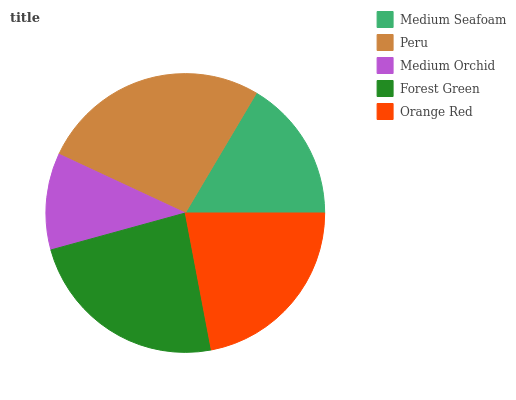Is Medium Orchid the minimum?
Answer yes or no. Yes. Is Peru the maximum?
Answer yes or no. Yes. Is Peru the minimum?
Answer yes or no. No. Is Medium Orchid the maximum?
Answer yes or no. No. Is Peru greater than Medium Orchid?
Answer yes or no. Yes. Is Medium Orchid less than Peru?
Answer yes or no. Yes. Is Medium Orchid greater than Peru?
Answer yes or no. No. Is Peru less than Medium Orchid?
Answer yes or no. No. Is Orange Red the high median?
Answer yes or no. Yes. Is Orange Red the low median?
Answer yes or no. Yes. Is Forest Green the high median?
Answer yes or no. No. Is Medium Seafoam the low median?
Answer yes or no. No. 